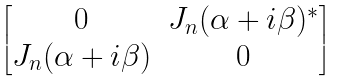<formula> <loc_0><loc_0><loc_500><loc_500>\begin{bmatrix} 0 & J _ { n } ( \alpha + i \beta ) ^ { * } \\ J _ { n } ( \alpha + i \beta ) & 0 \end{bmatrix}</formula> 